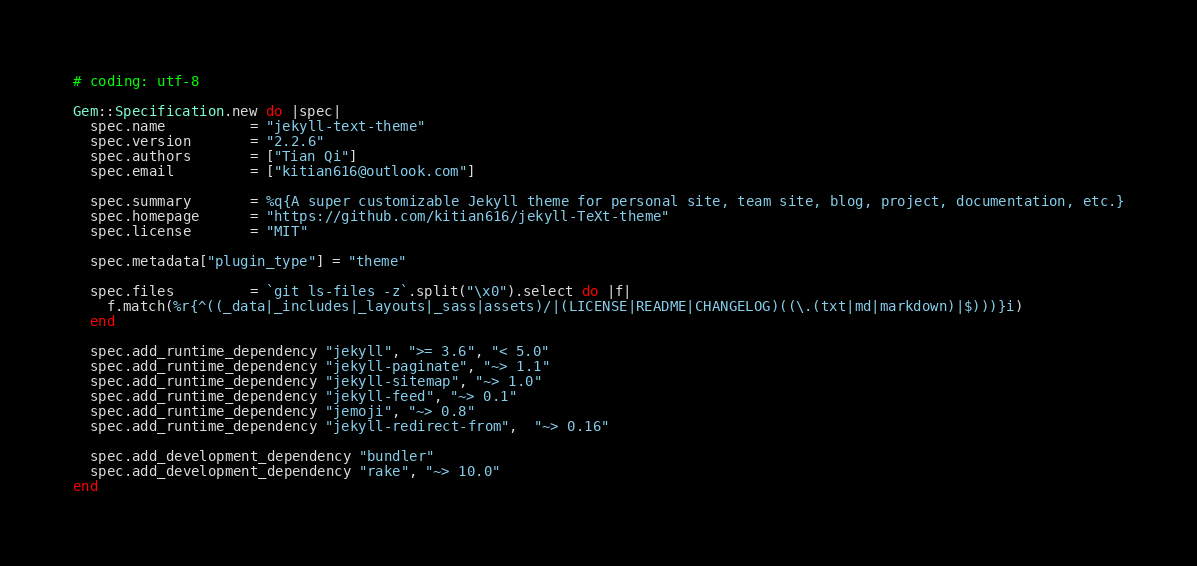<code> <loc_0><loc_0><loc_500><loc_500><_Ruby_># coding: utf-8

Gem::Specification.new do |spec|
  spec.name          = "jekyll-text-theme"
  spec.version       = "2.2.6"
  spec.authors       = ["Tian Qi"]
  spec.email         = ["kitian616@outlook.com"]

  spec.summary       = %q{A super customizable Jekyll theme for personal site, team site, blog, project, documentation, etc.}
  spec.homepage      = "https://github.com/kitian616/jekyll-TeXt-theme"
  spec.license       = "MIT"

  spec.metadata["plugin_type"] = "theme"

  spec.files         = `git ls-files -z`.split("\x0").select do |f|
    f.match(%r{^((_data|_includes|_layouts|_sass|assets)/|(LICENSE|README|CHANGELOG)((\.(txt|md|markdown)|$)))}i)
  end

  spec.add_runtime_dependency "jekyll", ">= 3.6", "< 5.0"
  spec.add_runtime_dependency "jekyll-paginate", "~> 1.1"
  spec.add_runtime_dependency "jekyll-sitemap", "~> 1.0"
  spec.add_runtime_dependency "jekyll-feed", "~> 0.1"
  spec.add_runtime_dependency "jemoji", "~> 0.8"
  spec.add_runtime_dependency "jekyll-redirect-from",  "~> 0.16"

  spec.add_development_dependency "bundler"
  spec.add_development_dependency "rake", "~> 10.0"
end
</code> 